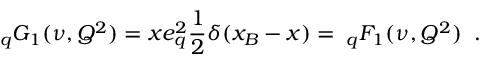<formula> <loc_0><loc_0><loc_500><loc_500>_ { q } G _ { 1 } ( \nu , Q ^ { 2 } ) = x e _ { q } ^ { 2 } { \frac { 1 } { 2 } } \delta ( x _ { B } - x ) = \, _ { q } F _ { 1 } ( \nu , Q ^ { 2 } ) \, .</formula> 